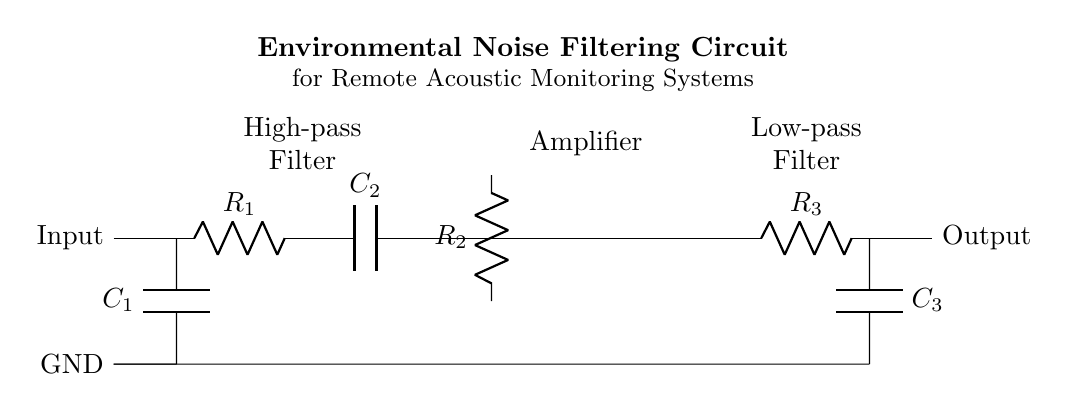What type of circuit is this? This is an environmental noise filtering circuit, as indicated by the title in the diagram. It suggests the purpose of the circuit, which is to filter noise in monitoring systems.
Answer: environmental noise filtering circuit What are the components present in the circuit? The diagram includes capacitors (C1, C2, C3), resistors (R1, R2, R3), and an operational amplifier. The labels next to each component clearly identify them.
Answer: capacitors, resistors, operational amplifier What is the function of the high-pass filter in this circuit? The high-pass filter, composed of R1 and C2, allows high-frequency signals to pass while attenuating lower frequencies, as suggested by its label and placement in the circuit flow.
Answer: allow high frequencies What is the purpose of the operational amplifier? The operational amplifier amplifies the voltage signal to enhance the output signal strength, as indicated by its placement in the circuit and the amplification functionality in circuits.
Answer: amplify the signal What is the configuration of the low-pass filter? The low-pass filter consists of R3 and C3, which, as per its label and arrangement in the circuit, filter out high-frequency components, allowing lower frequencies to pass through.
Answer: resistor and capacitor in series How do R2 and the operational amplifier interact in the circuit? R2 provides feedback to the operational amplifier, which affects the gain and stability of the amplification, reflecting fundamental principles of amplifier circuit design where feedback is crucial.
Answer: feedback resistor 